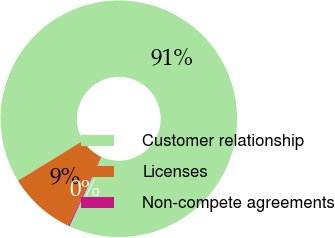Convert chart to OTSL. <chart><loc_0><loc_0><loc_500><loc_500><pie_chart><fcel>Customer relationship<fcel>Licenses<fcel>Non-compete agreements<nl><fcel>90.6%<fcel>9.22%<fcel>0.18%<nl></chart> 